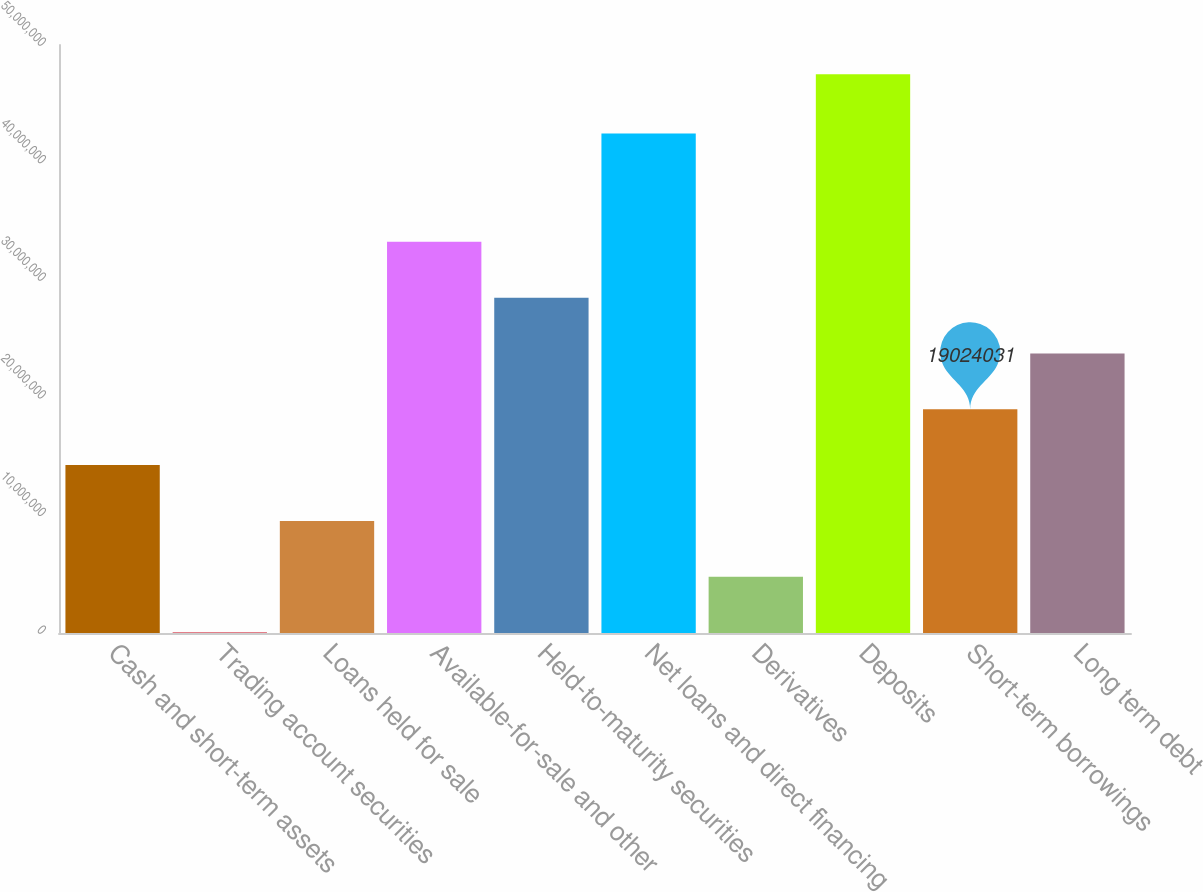Convert chart. <chart><loc_0><loc_0><loc_500><loc_500><bar_chart><fcel>Cash and short-term assets<fcel>Trading account securities<fcel>Loans held for sale<fcel>Available-for-sale and other<fcel>Held-to-maturity securities<fcel>Net loans and direct financing<fcel>Derivatives<fcel>Deposits<fcel>Short-term borrowings<fcel>Long term debt<nl><fcel>1.42769e+07<fcel>35573<fcel>9.5298e+06<fcel>3.32654e+07<fcel>2.85183e+07<fcel>4.24726e+07<fcel>4.78269e+06<fcel>4.75067e+07<fcel>1.9024e+07<fcel>2.37711e+07<nl></chart> 